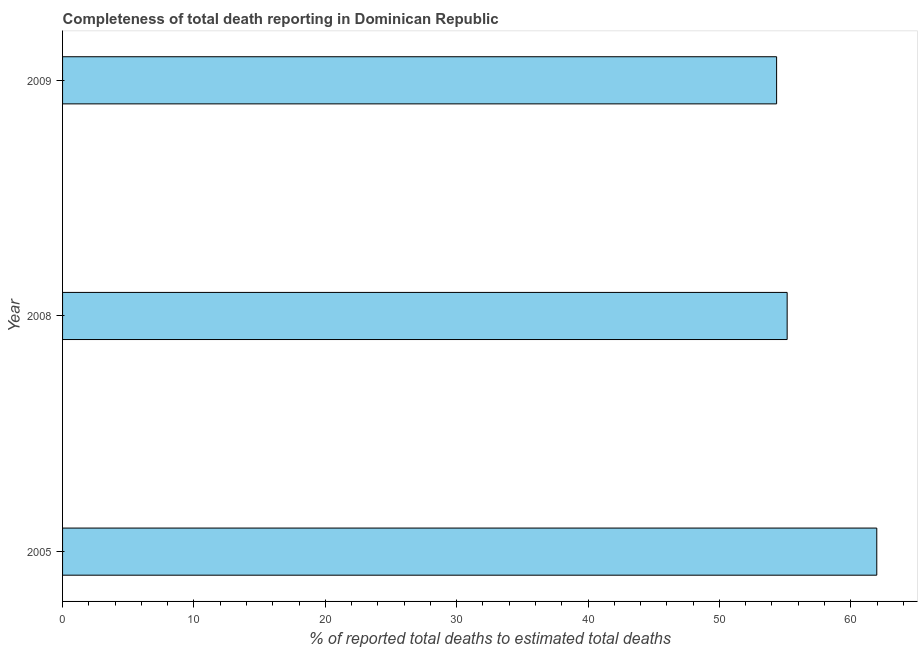What is the title of the graph?
Your answer should be compact. Completeness of total death reporting in Dominican Republic. What is the label or title of the X-axis?
Offer a very short reply. % of reported total deaths to estimated total deaths. What is the completeness of total death reports in 2008?
Your response must be concise. 55.16. Across all years, what is the maximum completeness of total death reports?
Your answer should be very brief. 61.98. Across all years, what is the minimum completeness of total death reports?
Provide a short and direct response. 54.36. What is the sum of the completeness of total death reports?
Offer a very short reply. 171.5. What is the difference between the completeness of total death reports in 2005 and 2009?
Provide a succinct answer. 7.63. What is the average completeness of total death reports per year?
Your answer should be compact. 57.16. What is the median completeness of total death reports?
Your answer should be compact. 55.16. In how many years, is the completeness of total death reports greater than 14 %?
Your answer should be very brief. 3. Is the difference between the completeness of total death reports in 2005 and 2008 greater than the difference between any two years?
Ensure brevity in your answer.  No. What is the difference between the highest and the second highest completeness of total death reports?
Your answer should be very brief. 6.82. Is the sum of the completeness of total death reports in 2005 and 2008 greater than the maximum completeness of total death reports across all years?
Offer a very short reply. Yes. What is the difference between the highest and the lowest completeness of total death reports?
Your answer should be compact. 7.63. How many years are there in the graph?
Your answer should be compact. 3. Are the values on the major ticks of X-axis written in scientific E-notation?
Provide a succinct answer. No. What is the % of reported total deaths to estimated total deaths of 2005?
Offer a terse response. 61.98. What is the % of reported total deaths to estimated total deaths in 2008?
Give a very brief answer. 55.16. What is the % of reported total deaths to estimated total deaths in 2009?
Ensure brevity in your answer.  54.36. What is the difference between the % of reported total deaths to estimated total deaths in 2005 and 2008?
Offer a very short reply. 6.82. What is the difference between the % of reported total deaths to estimated total deaths in 2005 and 2009?
Offer a very short reply. 7.63. What is the difference between the % of reported total deaths to estimated total deaths in 2008 and 2009?
Your answer should be very brief. 0.8. What is the ratio of the % of reported total deaths to estimated total deaths in 2005 to that in 2008?
Offer a very short reply. 1.12. What is the ratio of the % of reported total deaths to estimated total deaths in 2005 to that in 2009?
Your answer should be compact. 1.14. 